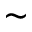<formula> <loc_0><loc_0><loc_500><loc_500>\sim</formula> 